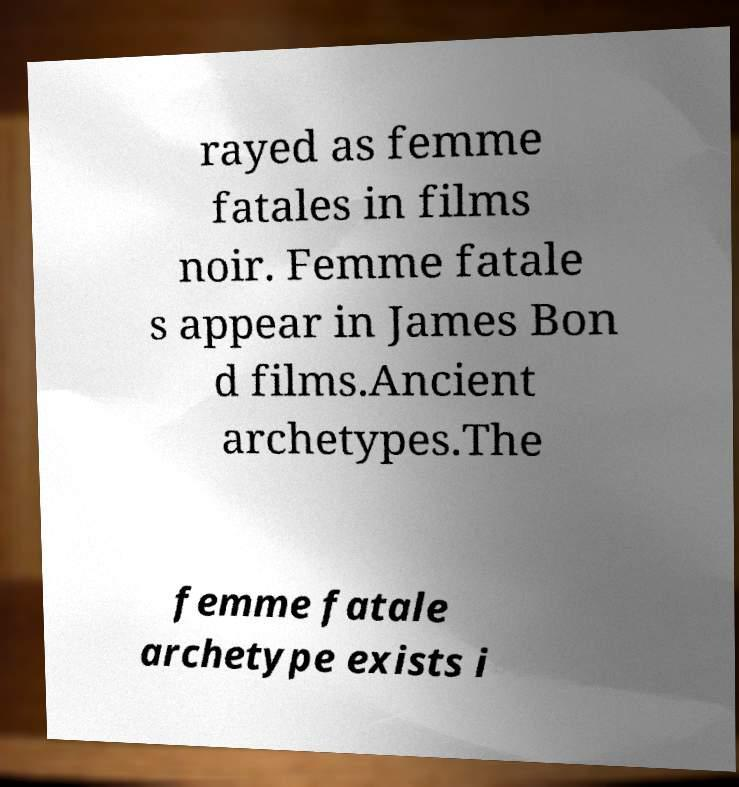What messages or text are displayed in this image? I need them in a readable, typed format. rayed as femme fatales in films noir. Femme fatale s appear in James Bon d films.Ancient archetypes.The femme fatale archetype exists i 